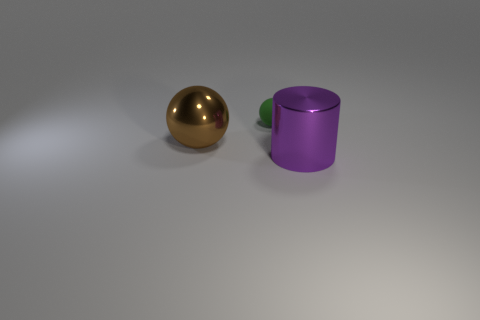What is the color of the large metallic thing that is the same shape as the small green object?
Make the answer very short. Brown. Does the tiny green rubber object have the same shape as the shiny thing right of the large brown shiny object?
Your answer should be compact. No. What number of objects are either things that are behind the brown metal object or tiny matte spheres that are on the left side of the big cylinder?
Your answer should be very brief. 1. What is the material of the purple cylinder?
Provide a short and direct response. Metal. How many other objects are the same size as the metal cylinder?
Offer a terse response. 1. There is a shiny object that is on the right side of the big sphere; what is its size?
Provide a short and direct response. Large. What is the tiny green object that is on the left side of the thing that is in front of the large metallic object that is left of the purple shiny cylinder made of?
Your answer should be very brief. Rubber. Is the shape of the brown metallic thing the same as the green rubber thing?
Give a very brief answer. Yes. What number of rubber objects are large purple cylinders or big cyan cylinders?
Provide a short and direct response. 0. How many big purple metallic spheres are there?
Provide a succinct answer. 0. 